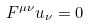Convert formula to latex. <formula><loc_0><loc_0><loc_500><loc_500>F ^ { \mu \nu } u _ { \nu } = 0</formula> 